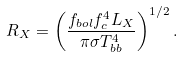Convert formula to latex. <formula><loc_0><loc_0><loc_500><loc_500>R _ { X } = \left ( \frac { f _ { b o l } f _ { c } ^ { 4 } L _ { X } } { \pi \sigma T _ { b b } ^ { 4 } } \right ) ^ { 1 / 2 } .</formula> 